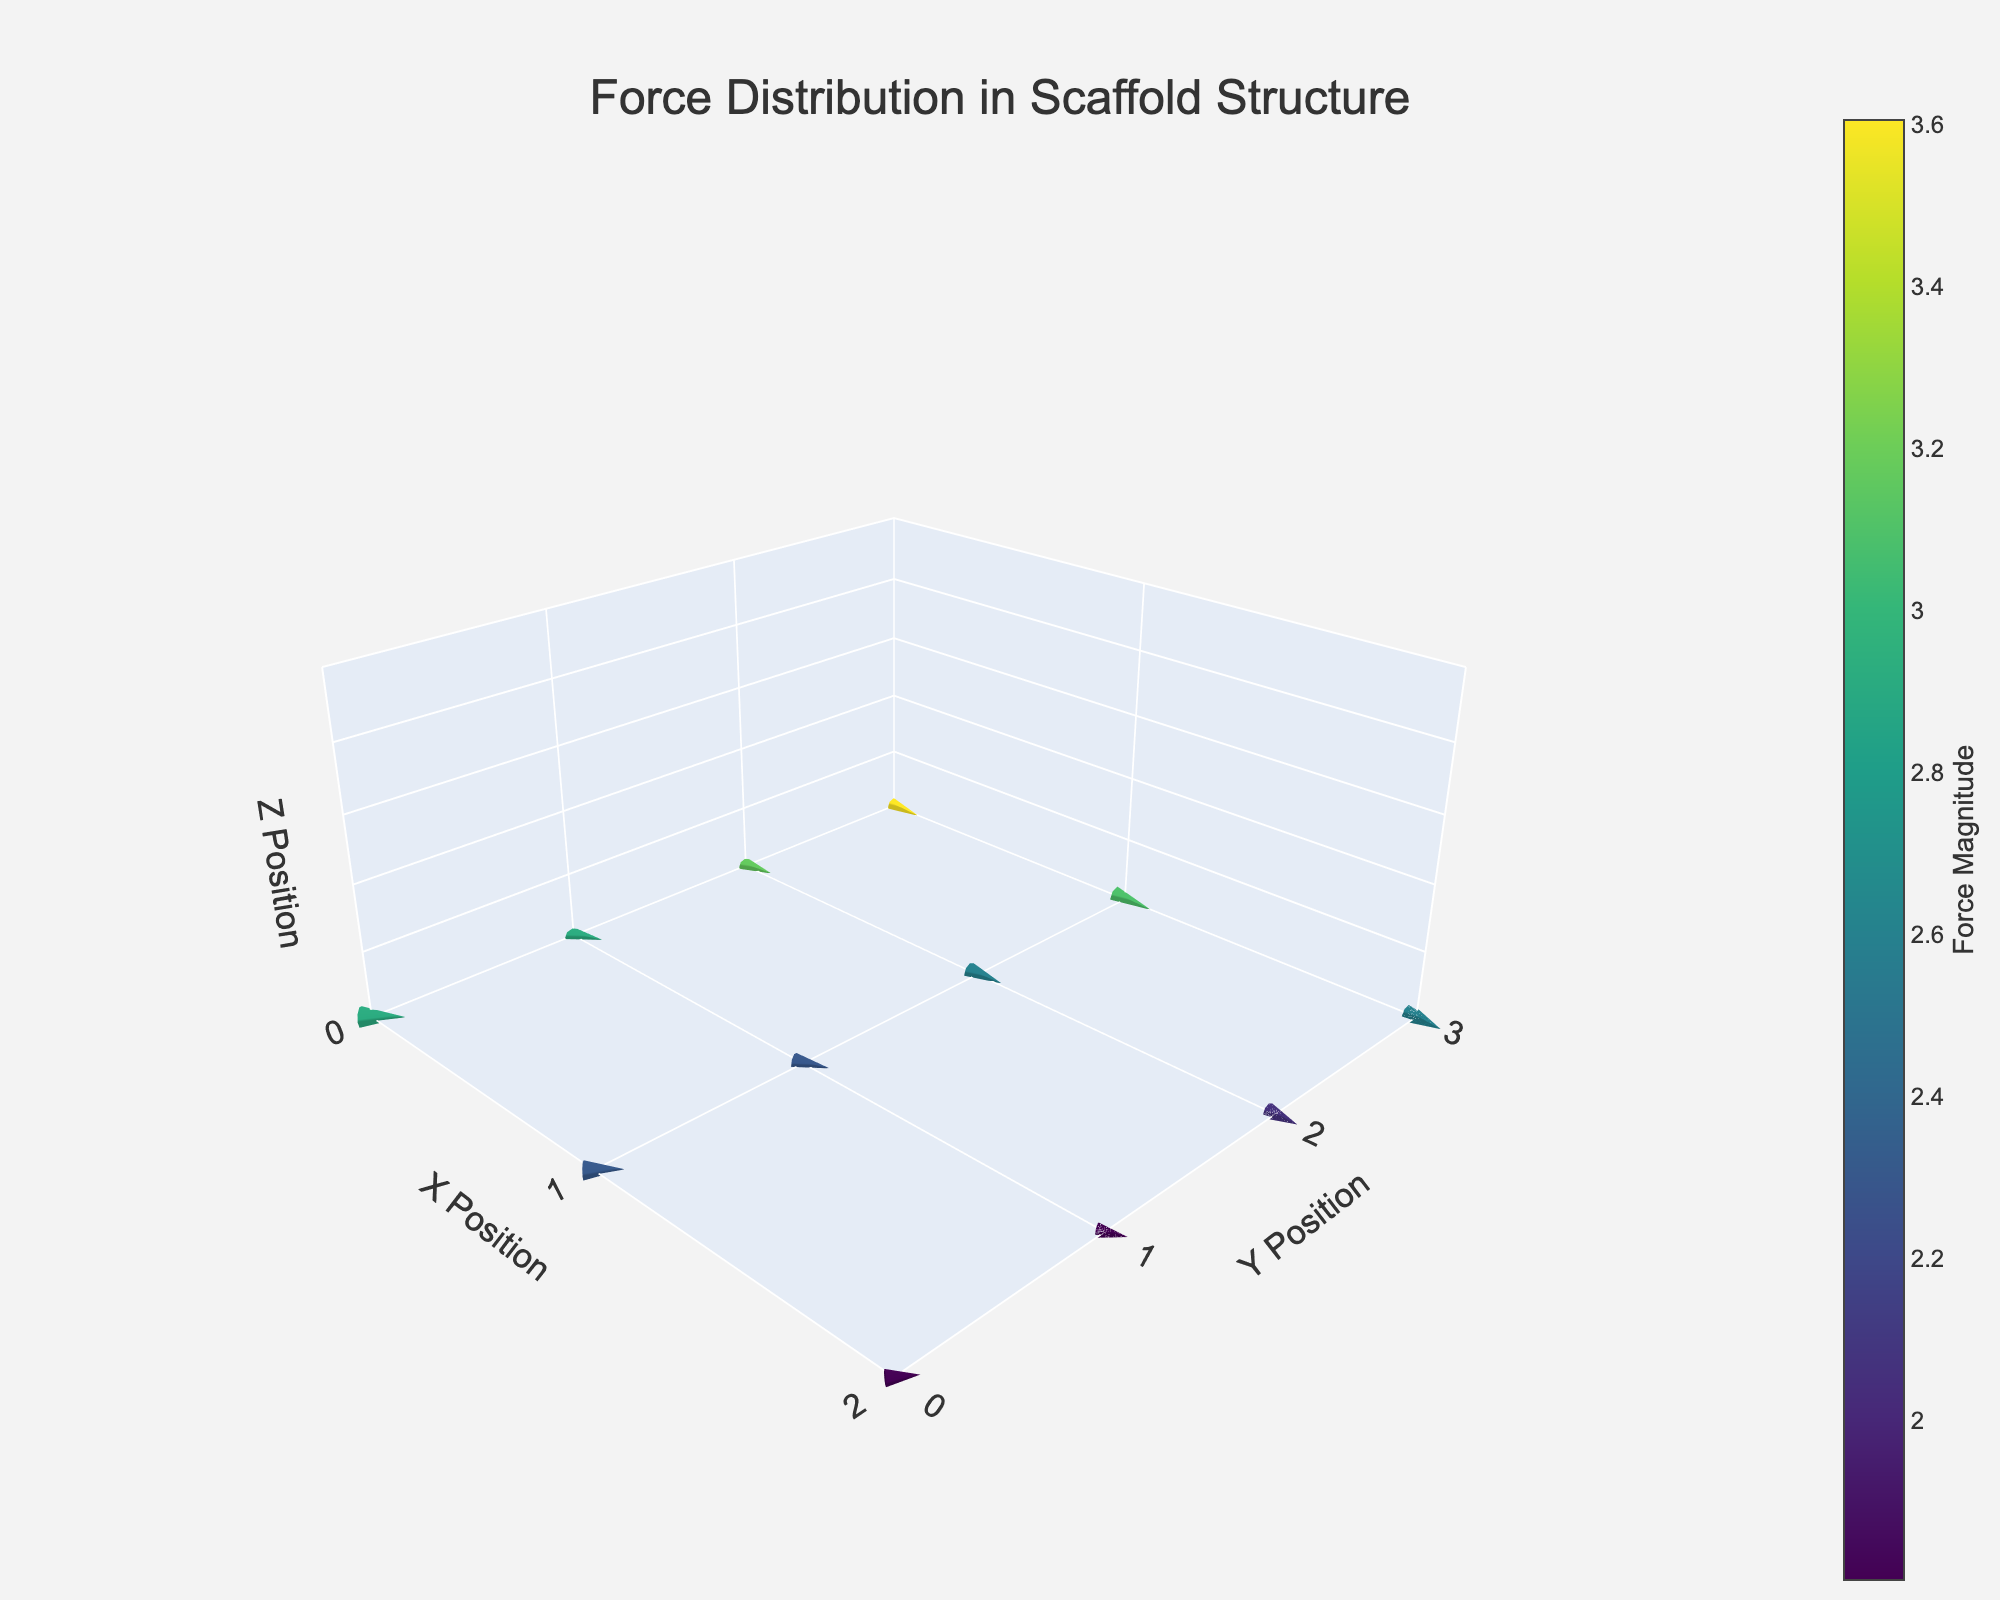How many data points are shown in the figure? The figure has data points represented by arrows, and each arrow comes from the given dataset. By counting the rows in the dataset, we see there are 12 data points.
Answer: 12 What is the maximum force magnitude shown, and where is it located? The maximum force magnitude can be found by identifying the highest value in the 'magnitude' column of the dataset, which is 3.6. This magnitude is located at the position where x=0 and y=0.
Answer: 3.6 at (0, 0) Among the positions (1, 2) and (2, 1), which one has a higher force magnitude? To determine the higher force magnitude among these positions, compare the magnitudes at (1, 2) and (2, 1). The magnitudes are 2.5 and 1.8, respectively, thus (1, 2) has a higher force magnitude.
Answer: (1, 2) What is the average force magnitude for points in the x=1 column? Calculate the average by summing the magnitudes corresponding to x=1 (2.9, 2.5, 2.5, 3.0) and dividing by the number of points. (2.9 + 2.5 + 2.5 + 3.0) / 4 = 10.9 / 4 = 2.725
Answer: 2.725 At which positions are the forces directed straight upwards? Forces directed straight upwards have v components greater than 0 and u component equal to 0. From the dataset, no forces meet this criteria.
Answer: None Which point has the smallest force magnitude, and what is its value? Identify the smallest magnitude in the dataset, which is found to be 1.8 at the position (2, 1) by looking at the 'magnitude' column.
Answer: 1.8 at (2, 1) Describe the direction of the force at position (0, 2). Is it more horizontal or vertical? The force at (0, 2) has components u=3 and v=1. Since the horizontal component u is greater than the vertical component v, the force is more horizontal.
Answer: More horizontal How does the force vector at (0, 3) compare with the force vector at (2, 3) with respect to direction? The force at (0, 3) has u=3.5, v=0 (horizontal right), while (2, 3) has u=2.5, v=-0.5 (slightly downward). They point in different directions: right vs. downward-right.
Answer: Different directions What is the total force magnitude for all positions combined in the y=2 row? Sum the magnitudes for the y=2 row: 3.2 (0, 2) + 2.5 (1, 2) + 2.0 (2, 2) = 7.7
Answer: 7.7 Is there any point with no horizontal force component? A point with no horizontal force component has u=0. Examining the dataset, there are no such points.
Answer: No 